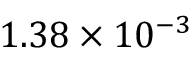Convert formula to latex. <formula><loc_0><loc_0><loc_500><loc_500>1 . 3 8 \times 1 0 ^ { - 3 }</formula> 